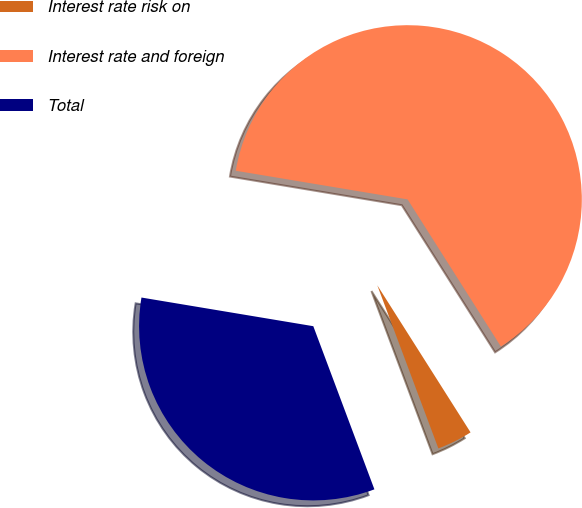Convert chart. <chart><loc_0><loc_0><loc_500><loc_500><pie_chart><fcel>Interest rate risk on<fcel>Interest rate and foreign<fcel>Total<nl><fcel>3.29%<fcel>63.37%<fcel>33.33%<nl></chart> 